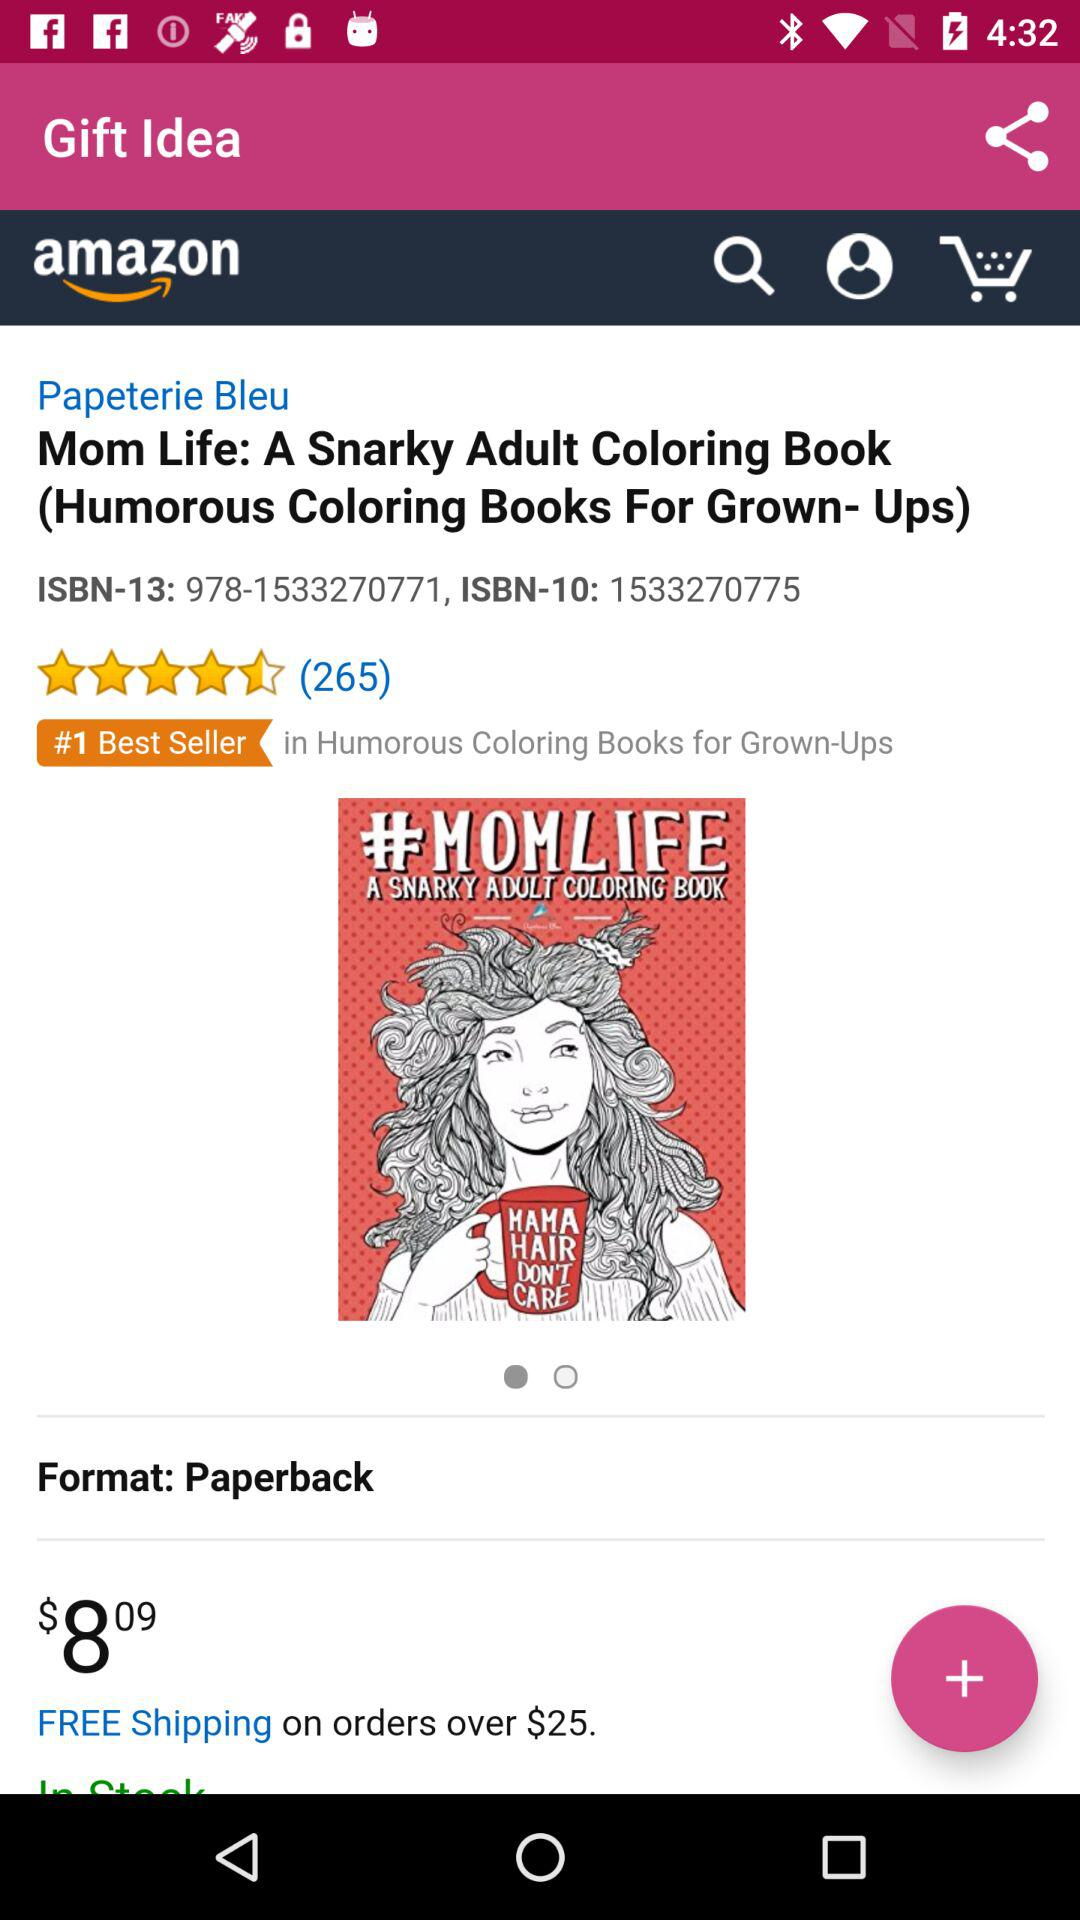Is the book available in hardcover?
When the provided information is insufficient, respond with <no answer>. <no answer> 